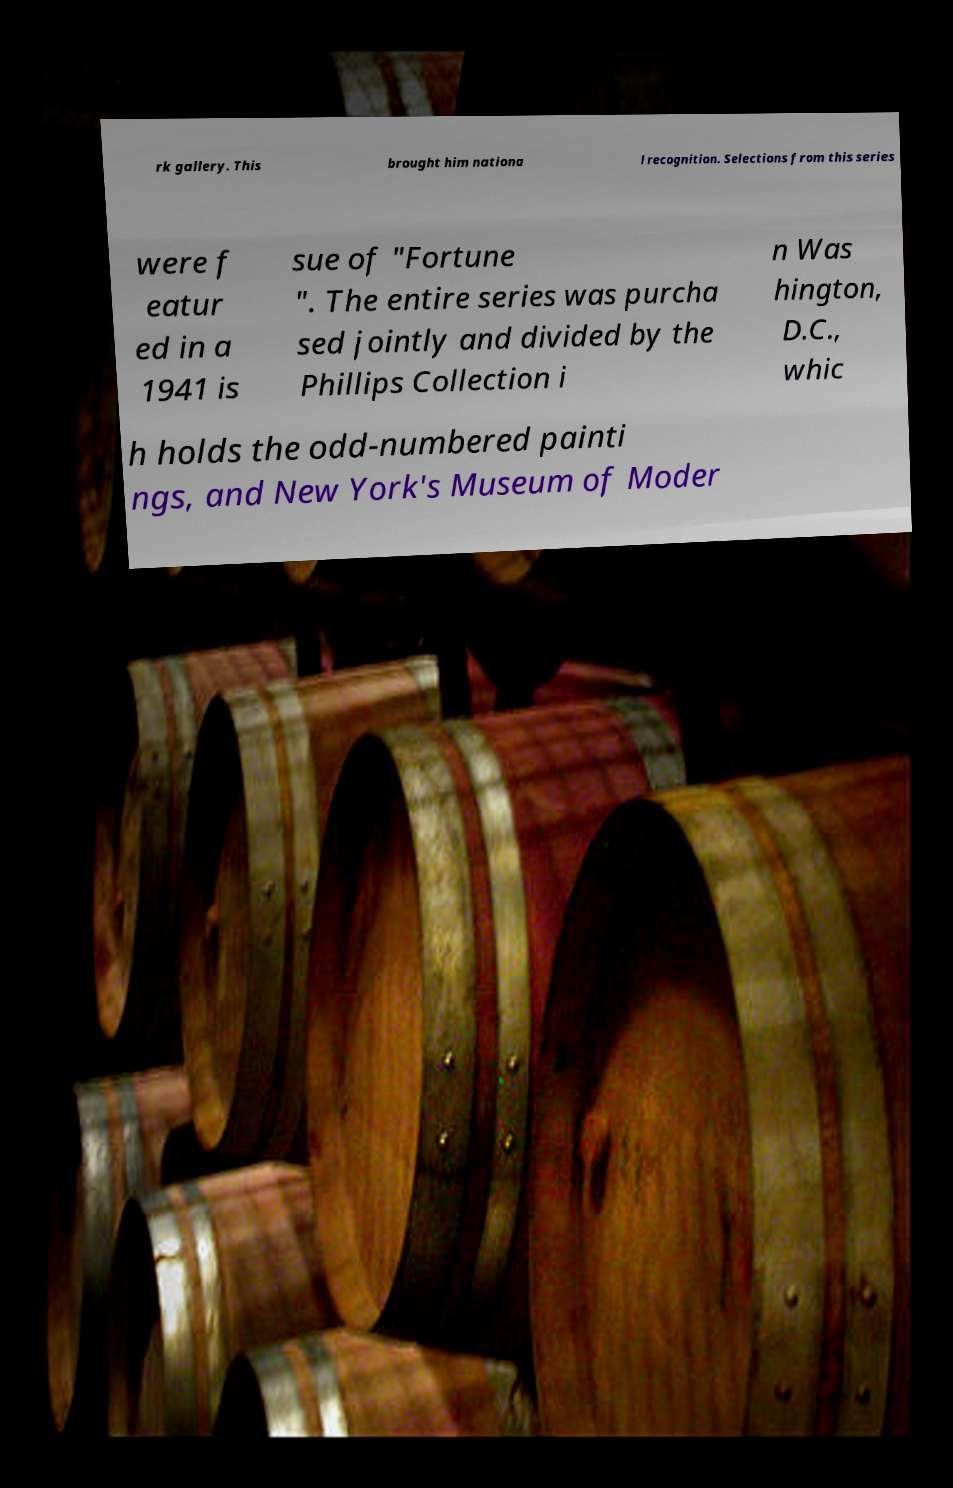For documentation purposes, I need the text within this image transcribed. Could you provide that? rk gallery. This brought him nationa l recognition. Selections from this series were f eatur ed in a 1941 is sue of "Fortune ". The entire series was purcha sed jointly and divided by the Phillips Collection i n Was hington, D.C., whic h holds the odd-numbered painti ngs, and New York's Museum of Moder 